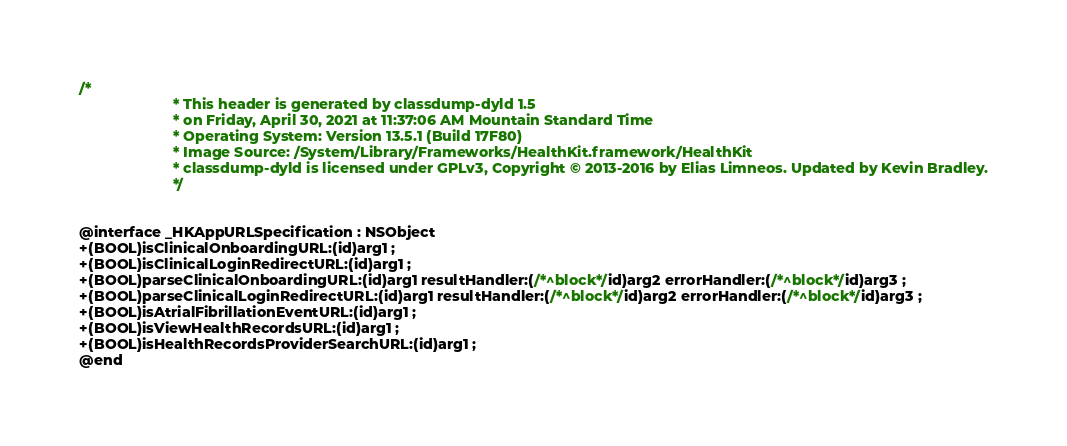<code> <loc_0><loc_0><loc_500><loc_500><_C_>/*
                       * This header is generated by classdump-dyld 1.5
                       * on Friday, April 30, 2021 at 11:37:06 AM Mountain Standard Time
                       * Operating System: Version 13.5.1 (Build 17F80)
                       * Image Source: /System/Library/Frameworks/HealthKit.framework/HealthKit
                       * classdump-dyld is licensed under GPLv3, Copyright © 2013-2016 by Elias Limneos. Updated by Kevin Bradley.
                       */


@interface _HKAppURLSpecification : NSObject
+(BOOL)isClinicalOnboardingURL:(id)arg1 ;
+(BOOL)isClinicalLoginRedirectURL:(id)arg1 ;
+(BOOL)parseClinicalOnboardingURL:(id)arg1 resultHandler:(/*^block*/id)arg2 errorHandler:(/*^block*/id)arg3 ;
+(BOOL)parseClinicalLoginRedirectURL:(id)arg1 resultHandler:(/*^block*/id)arg2 errorHandler:(/*^block*/id)arg3 ;
+(BOOL)isAtrialFibrillationEventURL:(id)arg1 ;
+(BOOL)isViewHealthRecordsURL:(id)arg1 ;
+(BOOL)isHealthRecordsProviderSearchURL:(id)arg1 ;
@end

</code> 